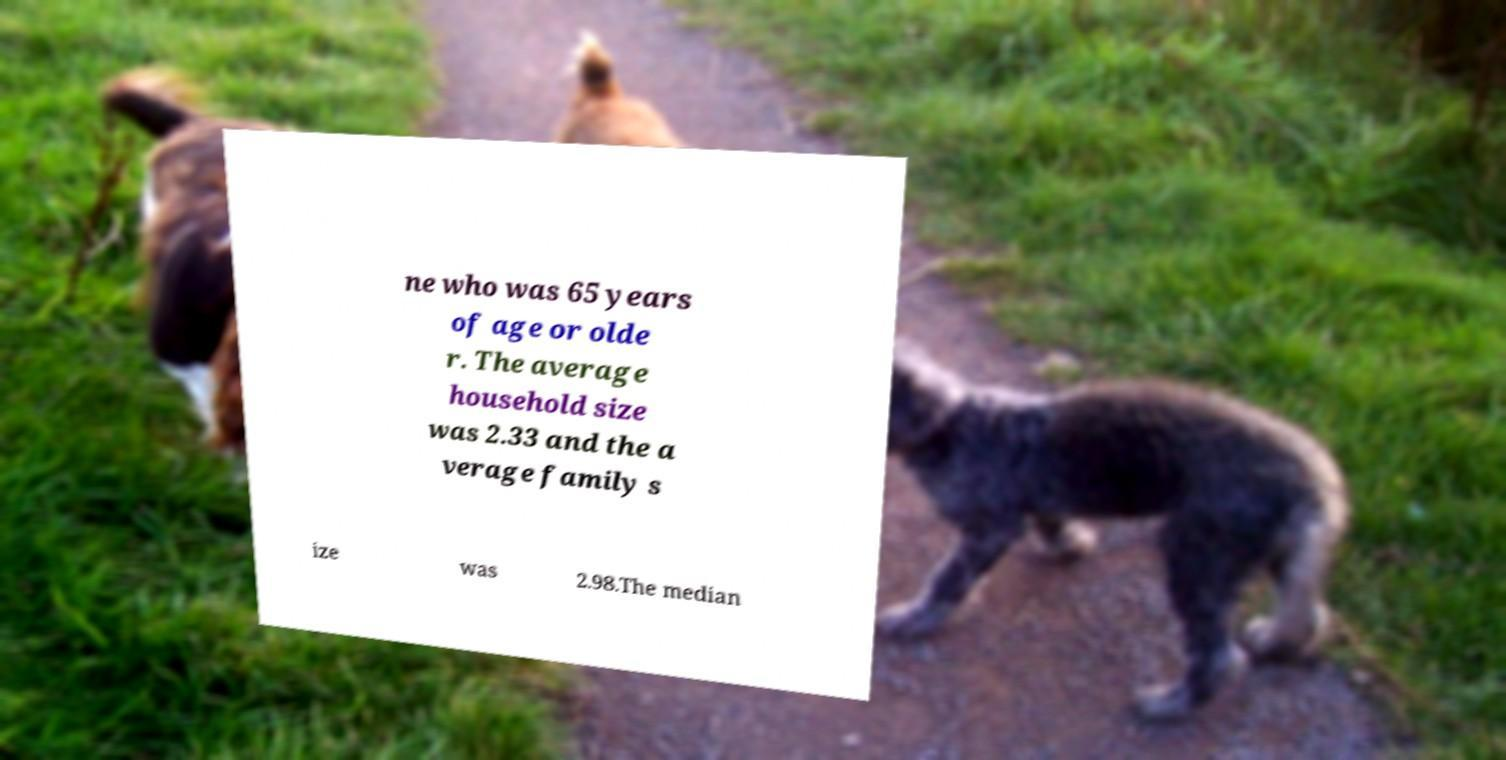What messages or text are displayed in this image? I need them in a readable, typed format. ne who was 65 years of age or olde r. The average household size was 2.33 and the a verage family s ize was 2.98.The median 